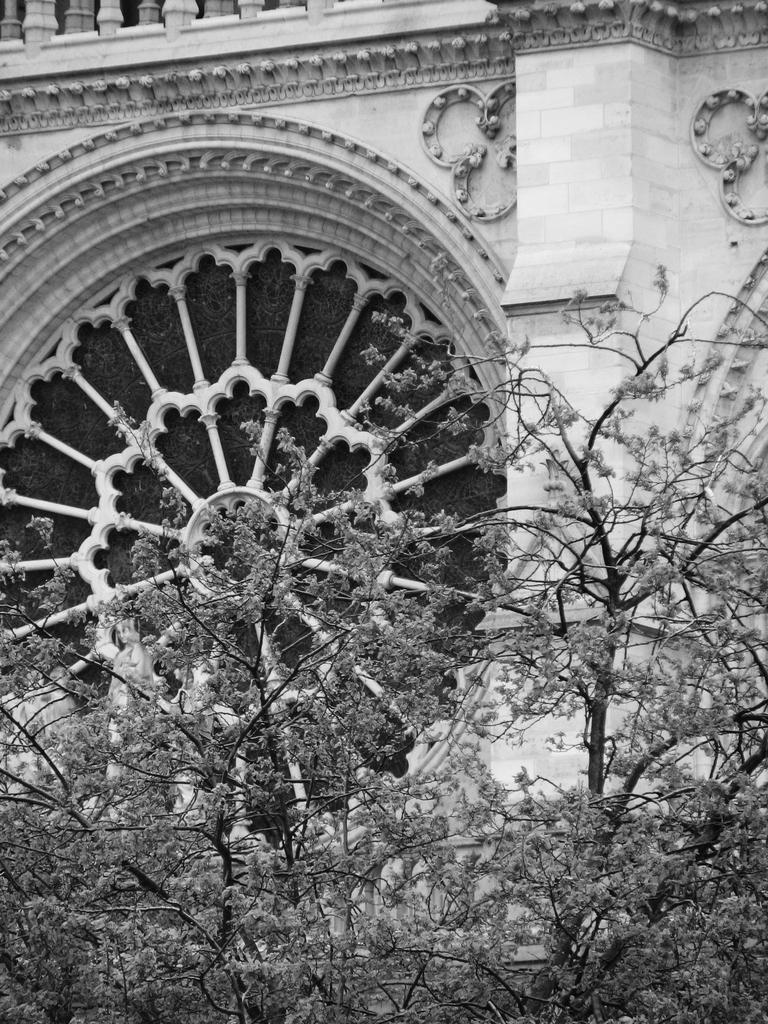What is the color scheme of the image? The image is black and white. What type of vegetation can be seen in the image? There are trees in the front of the image. What structure is visible behind the trees? There is a building behind the trees in the image. Can you hear the toy bursting in the image? There is no toy or sound present in the image, as it is a black and white image of trees and a building. 